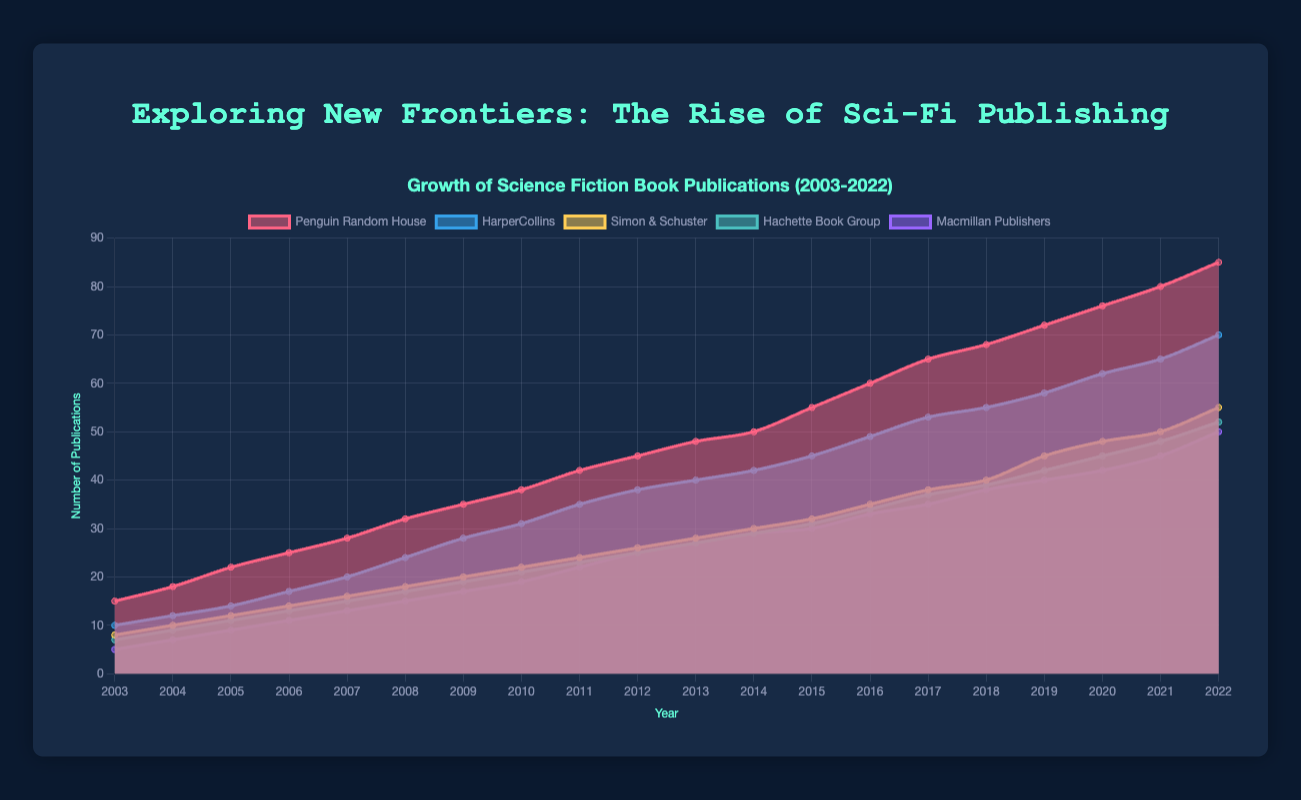What is the title of the chart? The title of the chart is located at the top, colored in greenish blue.
Answer: Exploring New Frontiers: The Rise of Sci-Fi Publishing Which publishing house has the most publications in 2022? By observing the highest point on the chart for 2022, the red area (Penguin Random House) reaches the topmost value.
Answer: Penguin Random House How many science fiction books did HarperCollins publish in 2020? The blue area representing HarperCollins shows a value of 62 in 2020.
Answer: 62 In which year did Penguin Random House start outperforming other publishers significantly? Around 2015, the red area representing Penguin Random House starts to increase more rapidly compared to others.
Answer: 2015 What was the approximate total number of publications in 2015 across all publishers? Sum up the values for each publisher in 2015: Penguin Random House (55) + HarperCollins (45) + Simon & Schuster (32) + Hachette Book Group (31) + Macmillan Publishers (30).
Answer: 193 Which publisher shows the steady growth over the entire period without noticeable dips? All areas show consistent growth, but Penguin Random House and HarperCollins have particularly steady areas.
Answer: Penguin Random House / HarperCollins When did Simon & Schuster reach the publication count of 50? The yellow area representing Simon & Schuster shows crossing the 50 mark in 2021.
Answer: 2021 By how much did the number of publications by Hachette Book Group increase from 2003 to 2022? Calculate the difference between the values for Hachette Book Group in 2022 (52) and 2003 (7).
Answer: 45 Compare the growth rate of Penguin Random House and Macmillan Publishers from 2003 to 2022. Which one had a faster growth rate? Penguin Random House increased by 70 (85 - 15), Macmillan Publishers increased by 45 (50 - 5), hence, Penguin Random House had a faster growth rate.
Answer: Penguin Random House Which publisher lead the publications in 2010, and how does it change over the next 12 years (through 2022)? In 2010, Penguin Random House had the lead at 38. Over the next 12 years, Penguin Random House continues to lead and extends its lead.
Answer: Penguin Random House, continues to lead 